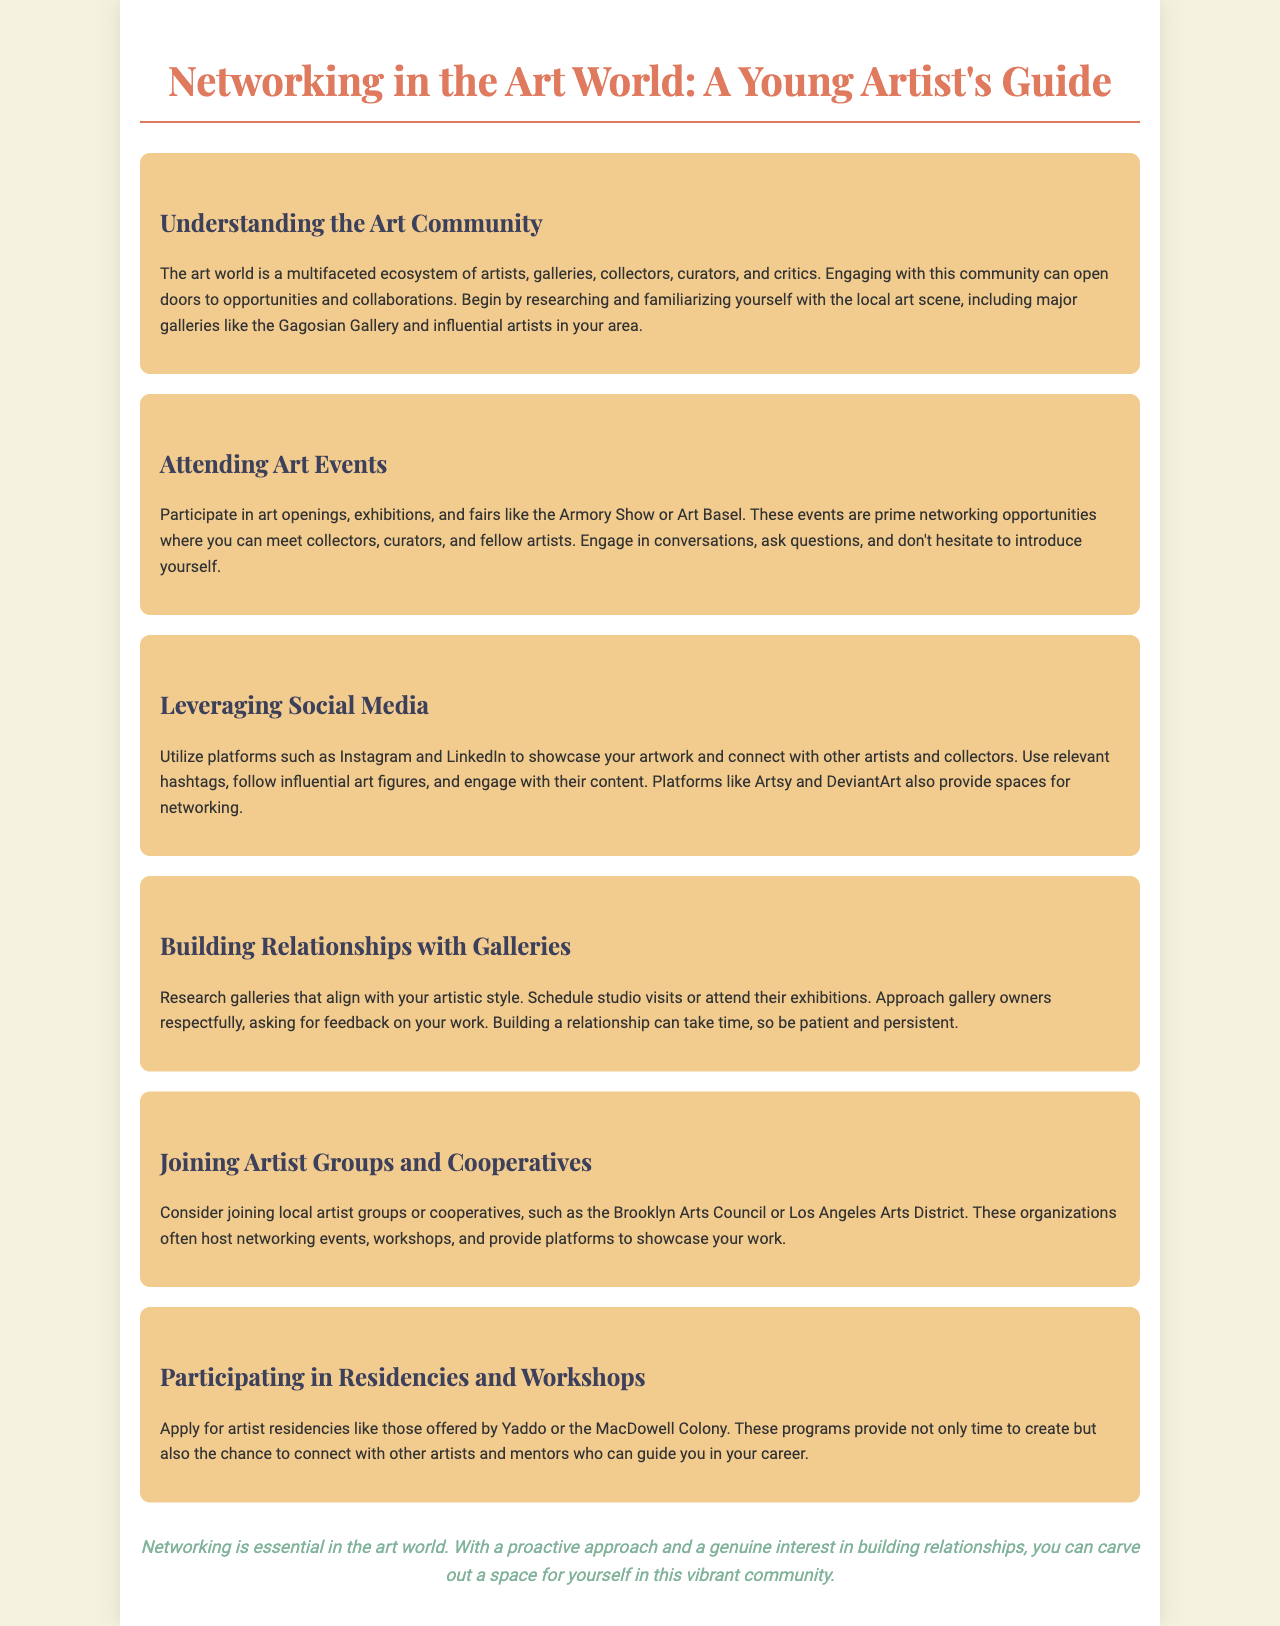What is the title of the brochure? The title is at the top of the document and indicates the main theme of the content, which is networking in the art world.
Answer: Networking in the Art World: A Young Artist's Guide What color is used for the title text? The color of the title text is specified in the styles, representing the branding and theme of the document.
Answer: #e07a5f What is one major art event mentioned? The document lists examples of art events to attend for networking opportunities, including well-known art fairs.
Answer: Art Basel Which platforms are recommended for leveraging social media? The text provides specific platforms where artists can showcase their work and connect with others.
Answer: Instagram and LinkedIn Name an organization suggested for joining local artist groups. The document mentions organizations that facilitate networking among artists in specific locations.
Answer: Brooklyn Arts Council What is one artist residency mentioned? The text cites specific residency programs where artists can gain time and connections for their work.
Answer: Yaddo What should you do to build relationships with galleries? The document advises on a respectful approach to galleries, including actions to help establish connections.
Answer: Schedule studio visits What is the closing message in the brochure? The closing statement reiterates the importance of networking and building relationships in the art community.
Answer: Networking is essential in the art world 